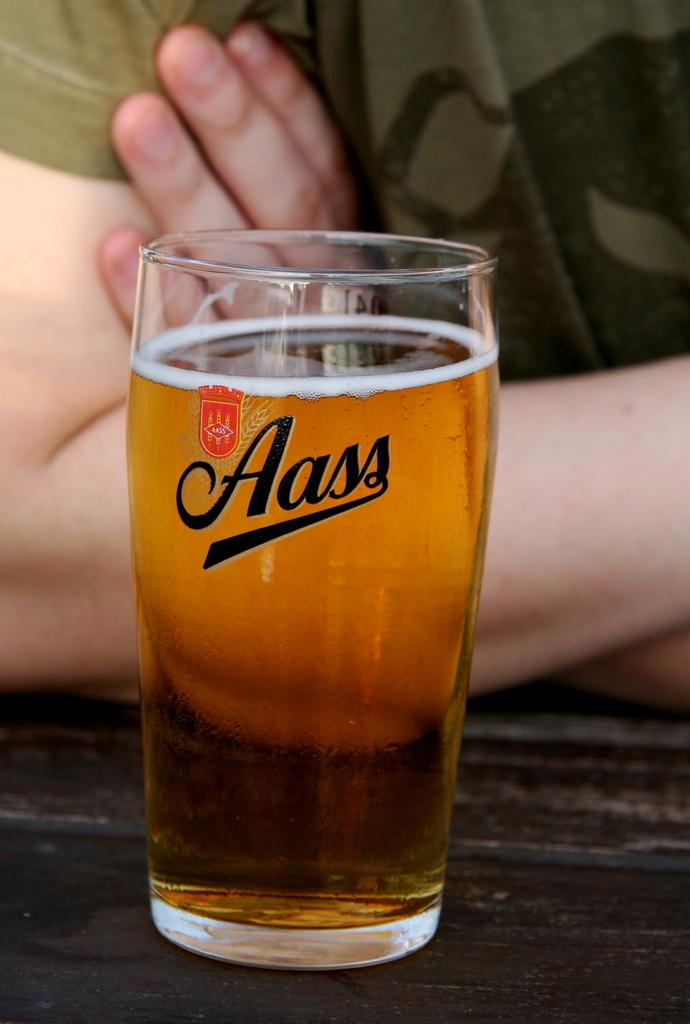What object is present in the image that is typically used for holding liquids? There is a glass in the image. Can you describe the person in front of the glass? The person in front of the glass has their face not visible. What color is the fifth person in the image? There is no mention of multiple people or colors in the provided facts, so it is not possible to answer this question. 